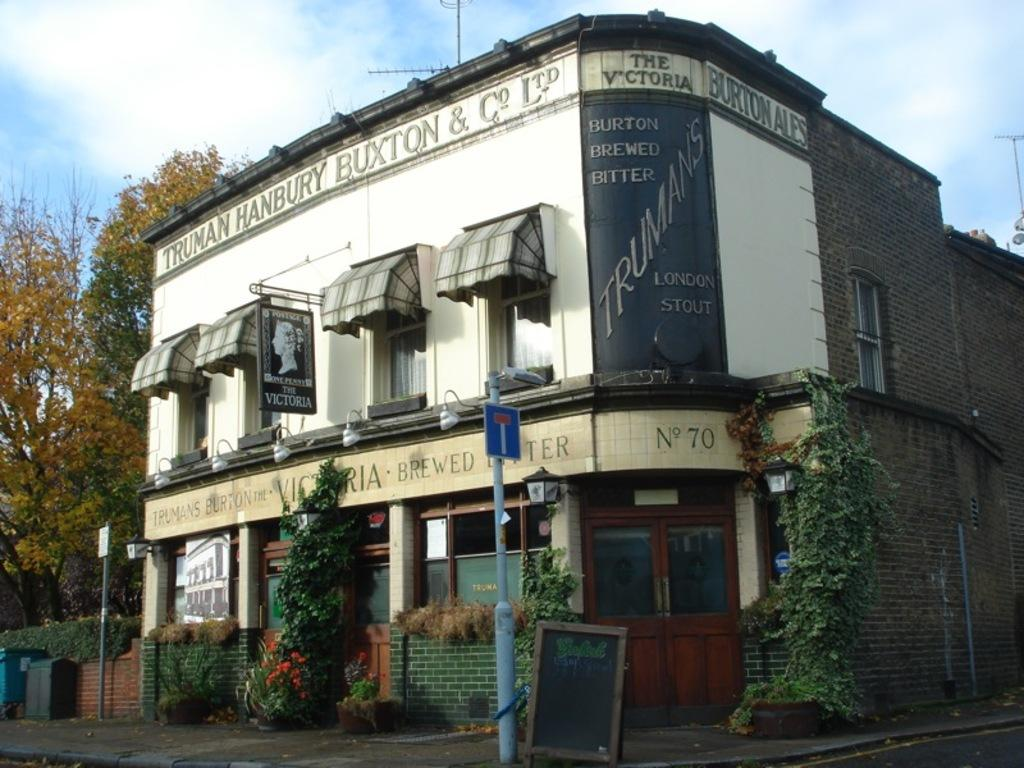What type of structures can be seen in the image? There are buildings in the image. What are some other objects present in the image? Street poles, street lights, creeper plants, information boards, trash bins, bushes, name boards, and trees are visible in the image. What can be seen in the sky in the image? The sky is visible in the image, and clouds are present in the sky. What type of attraction is depicted in the image? There is no specific attraction depicted in the image; it shows various elements of an urban environment. Can you tell me who created the trees in the image? The trees in the image are natural elements and not created by any individual or entity. 